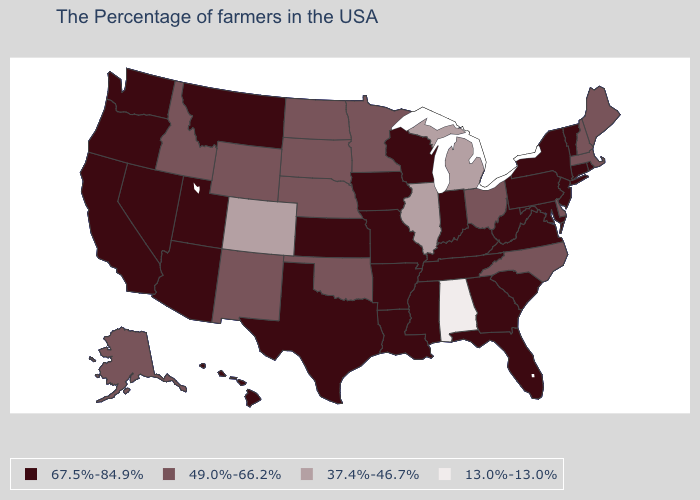Which states have the lowest value in the Northeast?
Be succinct. Maine, Massachusetts, New Hampshire. What is the lowest value in states that border Massachusetts?
Concise answer only. 49.0%-66.2%. What is the value of California?
Concise answer only. 67.5%-84.9%. Among the states that border North Dakota , which have the lowest value?
Quick response, please. Minnesota, South Dakota. How many symbols are there in the legend?
Concise answer only. 4. Does Washington have the same value as Delaware?
Answer briefly. No. What is the value of Arkansas?
Answer briefly. 67.5%-84.9%. What is the highest value in the MidWest ?
Short answer required. 67.5%-84.9%. Among the states that border Wisconsin , does Illinois have the lowest value?
Write a very short answer. Yes. Is the legend a continuous bar?
Write a very short answer. No. What is the value of Tennessee?
Quick response, please. 67.5%-84.9%. Name the states that have a value in the range 49.0%-66.2%?
Short answer required. Maine, Massachusetts, New Hampshire, Delaware, North Carolina, Ohio, Minnesota, Nebraska, Oklahoma, South Dakota, North Dakota, Wyoming, New Mexico, Idaho, Alaska. Name the states that have a value in the range 13.0%-13.0%?
Concise answer only. Alabama. Is the legend a continuous bar?
Concise answer only. No. What is the value of South Dakota?
Write a very short answer. 49.0%-66.2%. 